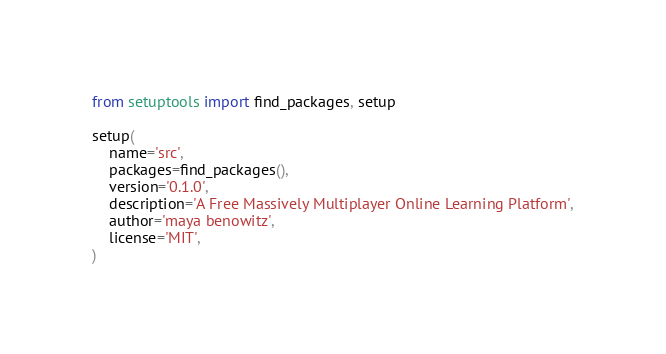<code> <loc_0><loc_0><loc_500><loc_500><_Python_>from setuptools import find_packages, setup

setup(
    name='src',
    packages=find_packages(),
    version='0.1.0',
    description='A Free Massively Multiplayer Online Learning Platform',
    author='maya benowitz',
    license='MIT',
)
</code> 